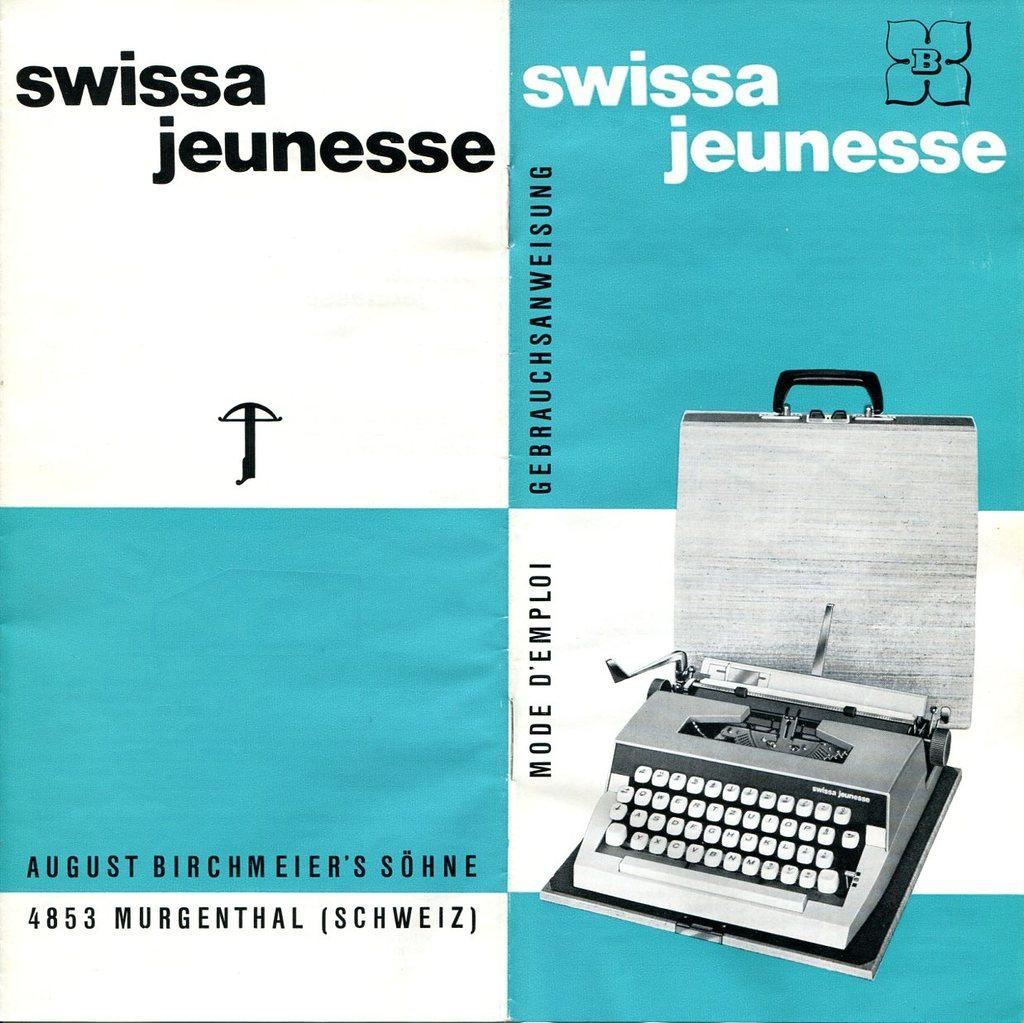<image>
Provide a brief description of the given image. A booklet for a Swissa Jeunesse typewriter and case. 